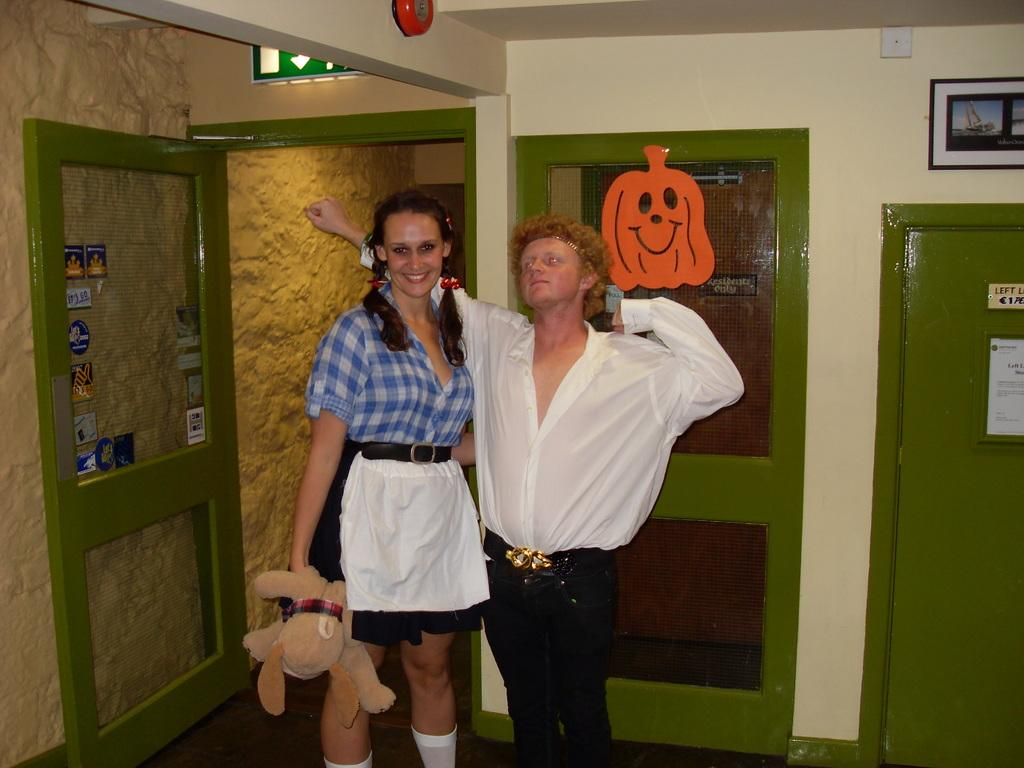How many people are present in the image? There are two people in the image. What can be seen in the background of the image? There is a wall, doors, posters, and some objects in the background of the image. Can you see a sister in the image? There is no mention of a sister in the image, so we cannot determine if one is present. Is there a swing visible in the image? There is no swing present in the image. 